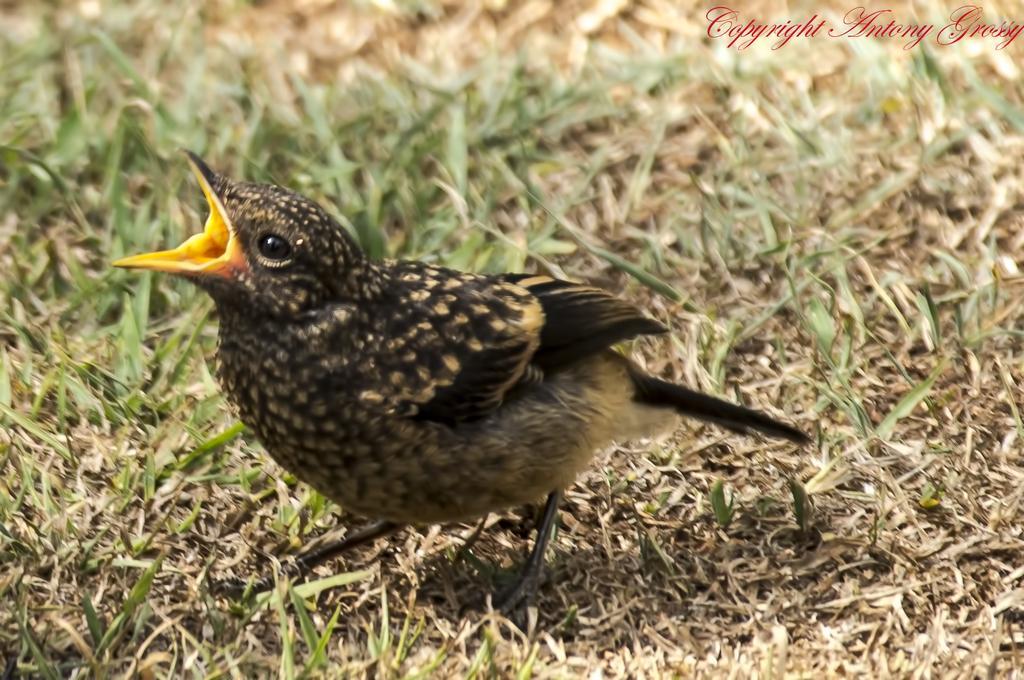Describe this image in one or two sentences. In this image, we can see a bird on the grass. Right side top corner, we can see a watermark in the image. 